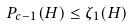Convert formula to latex. <formula><loc_0><loc_0><loc_500><loc_500>P _ { c - 1 } ( H ) \leq \zeta _ { 1 } ( H )</formula> 